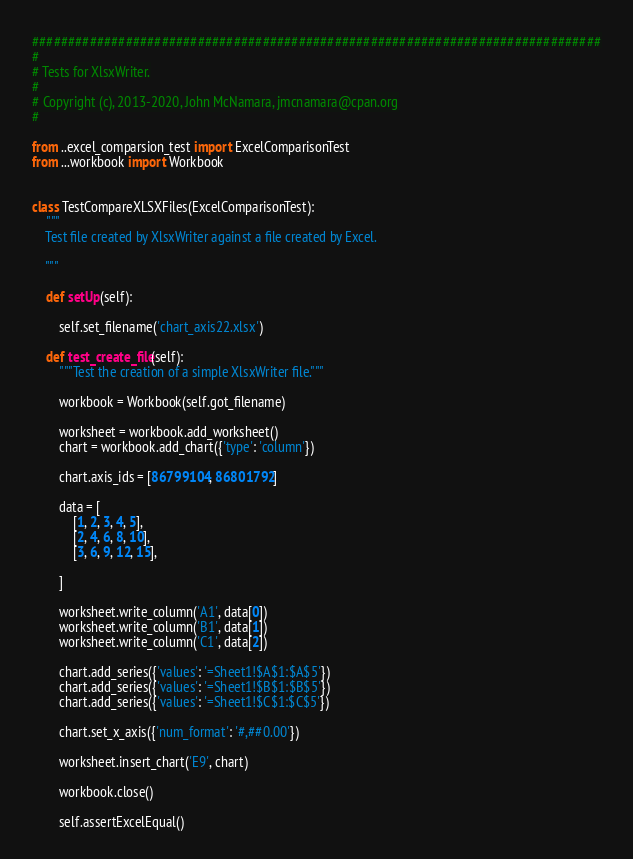<code> <loc_0><loc_0><loc_500><loc_500><_Python_>###############################################################################
#
# Tests for XlsxWriter.
#
# Copyright (c), 2013-2020, John McNamara, jmcnamara@cpan.org
#

from ..excel_comparsion_test import ExcelComparisonTest
from ...workbook import Workbook


class TestCompareXLSXFiles(ExcelComparisonTest):
    """
    Test file created by XlsxWriter against a file created by Excel.

    """

    def setUp(self):

        self.set_filename('chart_axis22.xlsx')

    def test_create_file(self):
        """Test the creation of a simple XlsxWriter file."""

        workbook = Workbook(self.got_filename)

        worksheet = workbook.add_worksheet()
        chart = workbook.add_chart({'type': 'column'})

        chart.axis_ids = [86799104, 86801792]

        data = [
            [1, 2, 3, 4, 5],
            [2, 4, 6, 8, 10],
            [3, 6, 9, 12, 15],

        ]

        worksheet.write_column('A1', data[0])
        worksheet.write_column('B1', data[1])
        worksheet.write_column('C1', data[2])

        chart.add_series({'values': '=Sheet1!$A$1:$A$5'})
        chart.add_series({'values': '=Sheet1!$B$1:$B$5'})
        chart.add_series({'values': '=Sheet1!$C$1:$C$5'})

        chart.set_x_axis({'num_format': '#,##0.00'})

        worksheet.insert_chart('E9', chart)

        workbook.close()

        self.assertExcelEqual()
</code> 